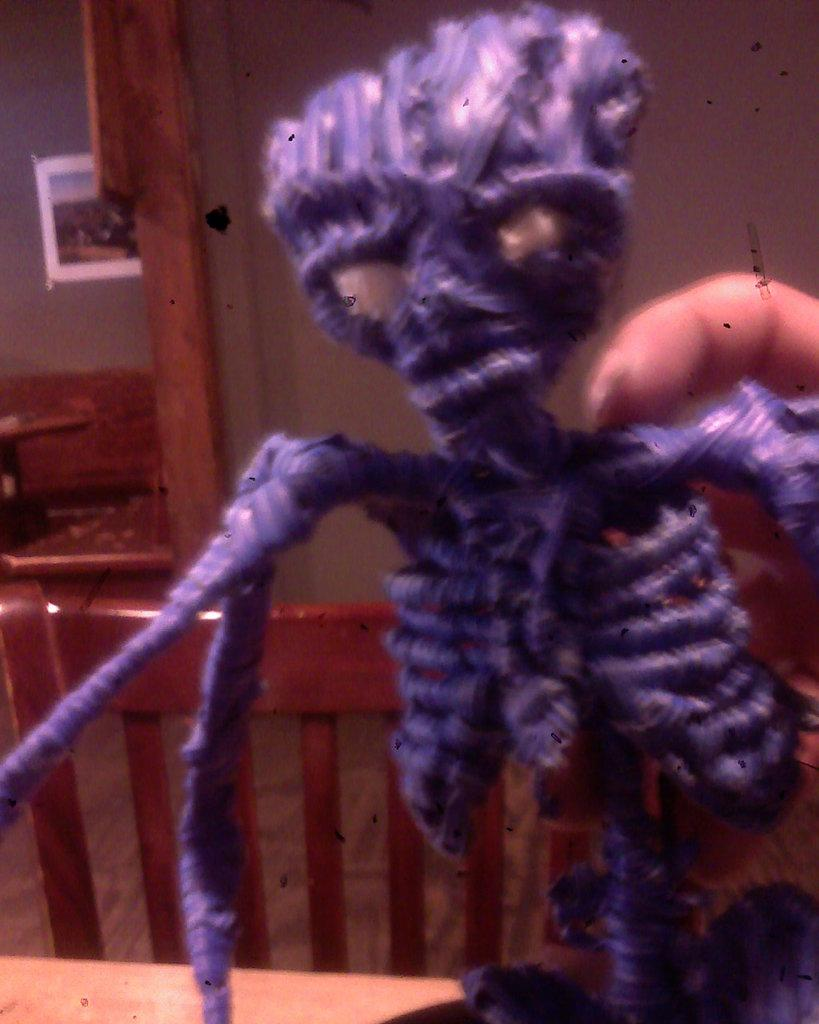What object in the image is designed for play? There is a toy in the image. What type of band is playing music in the image? There is no band present in the image; it only features a toy. What type of spy equipment can be seen in the image? There is no spy equipment present in the image; it only features a toy. 